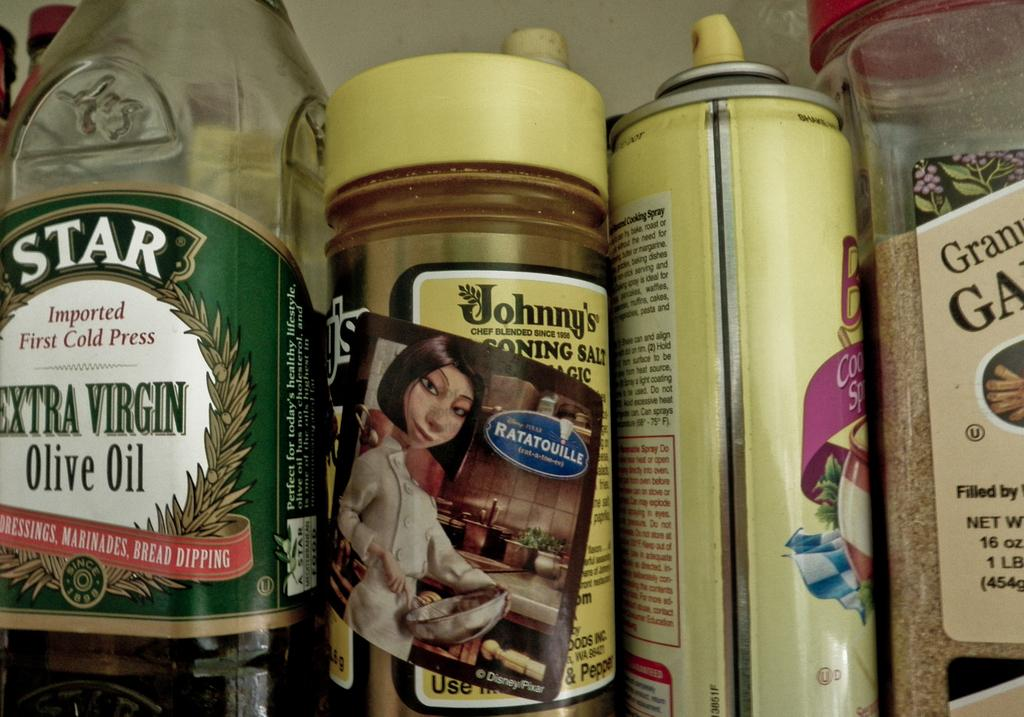<image>
Offer a succinct explanation of the picture presented. Several spices and oils in a kitchen, one of which reads EXTRA VIRGIN Olive Oil on the front. 